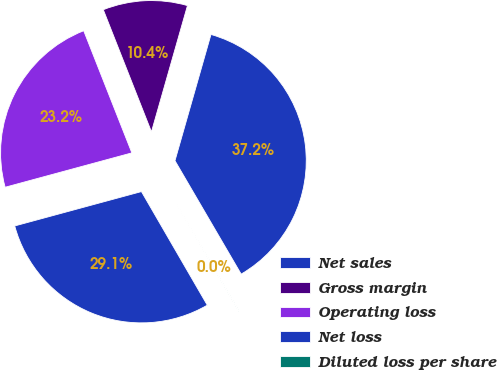<chart> <loc_0><loc_0><loc_500><loc_500><pie_chart><fcel>Net sales<fcel>Gross margin<fcel>Operating loss<fcel>Net loss<fcel>Diluted loss per share<nl><fcel>37.17%<fcel>10.4%<fcel>23.24%<fcel>29.15%<fcel>0.05%<nl></chart> 